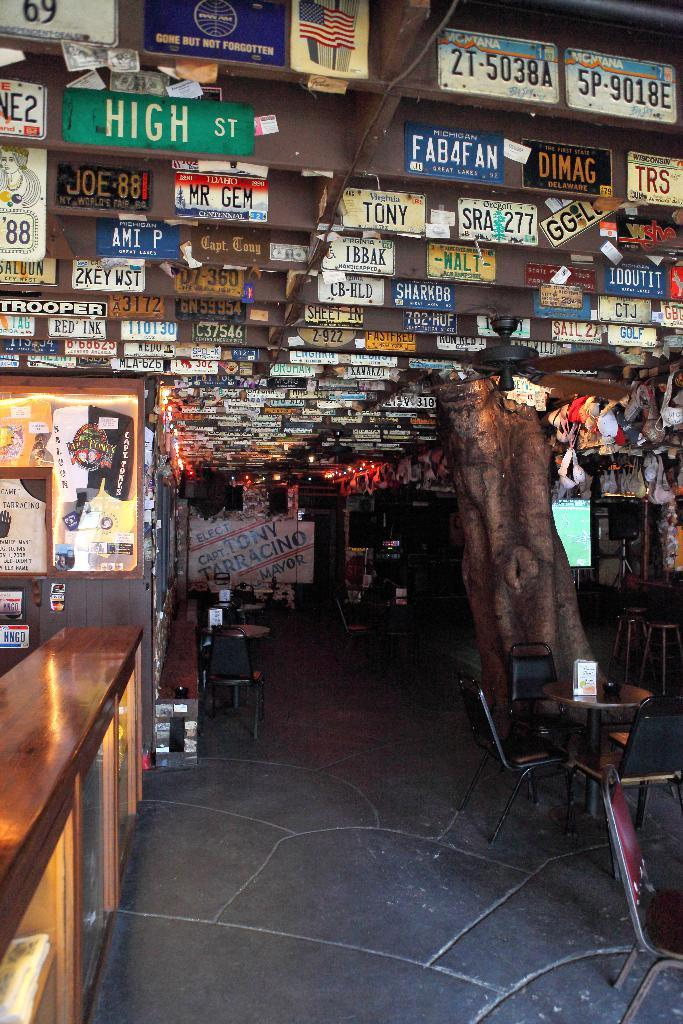<image>
Share a concise interpretation of the image provided. Many signs are on a restaurant's ceiling, including one that says High St. 